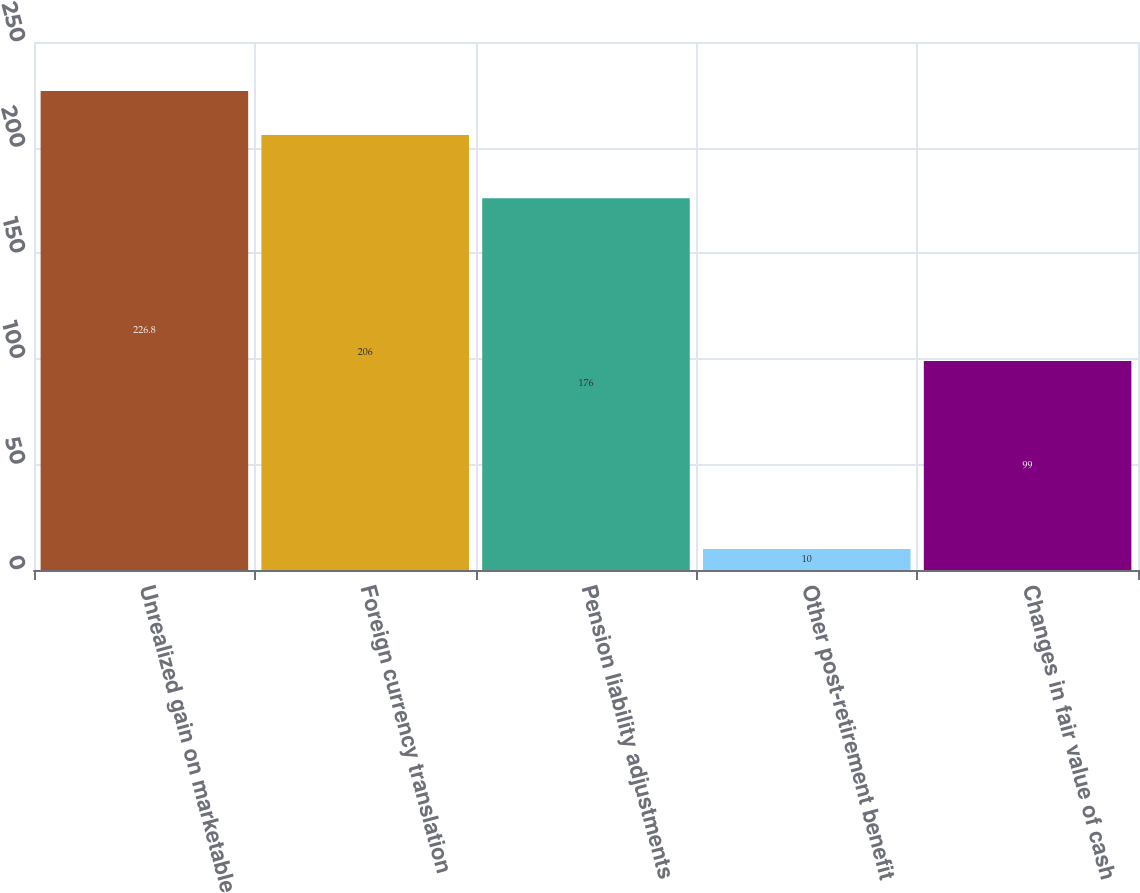<chart> <loc_0><loc_0><loc_500><loc_500><bar_chart><fcel>Unrealized gain on marketable<fcel>Foreign currency translation<fcel>Pension liability adjustments<fcel>Other post-retirement benefit<fcel>Changes in fair value of cash<nl><fcel>226.8<fcel>206<fcel>176<fcel>10<fcel>99<nl></chart> 